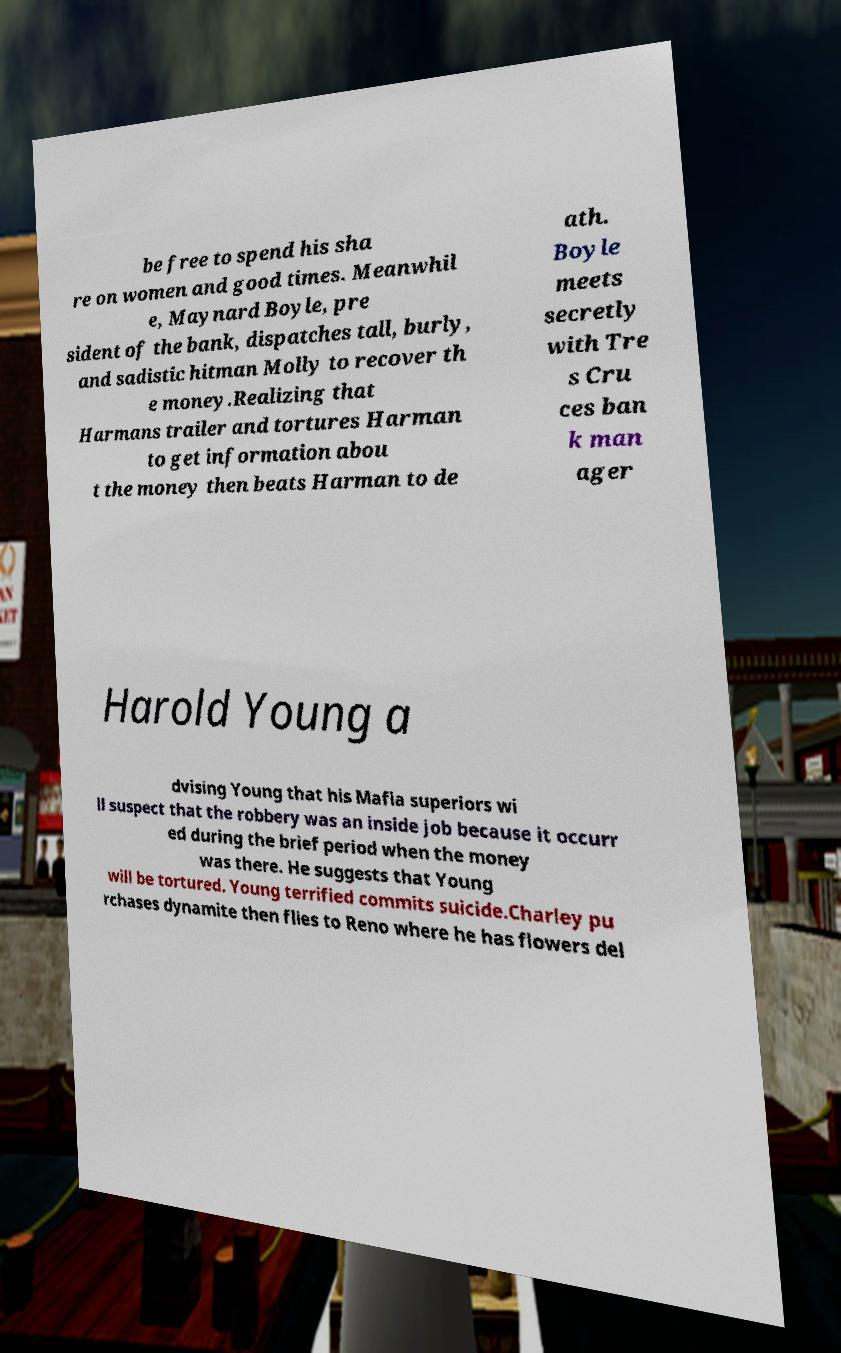There's text embedded in this image that I need extracted. Can you transcribe it verbatim? be free to spend his sha re on women and good times. Meanwhil e, Maynard Boyle, pre sident of the bank, dispatches tall, burly, and sadistic hitman Molly to recover th e money.Realizing that Harmans trailer and tortures Harman to get information abou t the money then beats Harman to de ath. Boyle meets secretly with Tre s Cru ces ban k man ager Harold Young a dvising Young that his Mafia superiors wi ll suspect that the robbery was an inside job because it occurr ed during the brief period when the money was there. He suggests that Young will be tortured. Young terrified commits suicide.Charley pu rchases dynamite then flies to Reno where he has flowers del 